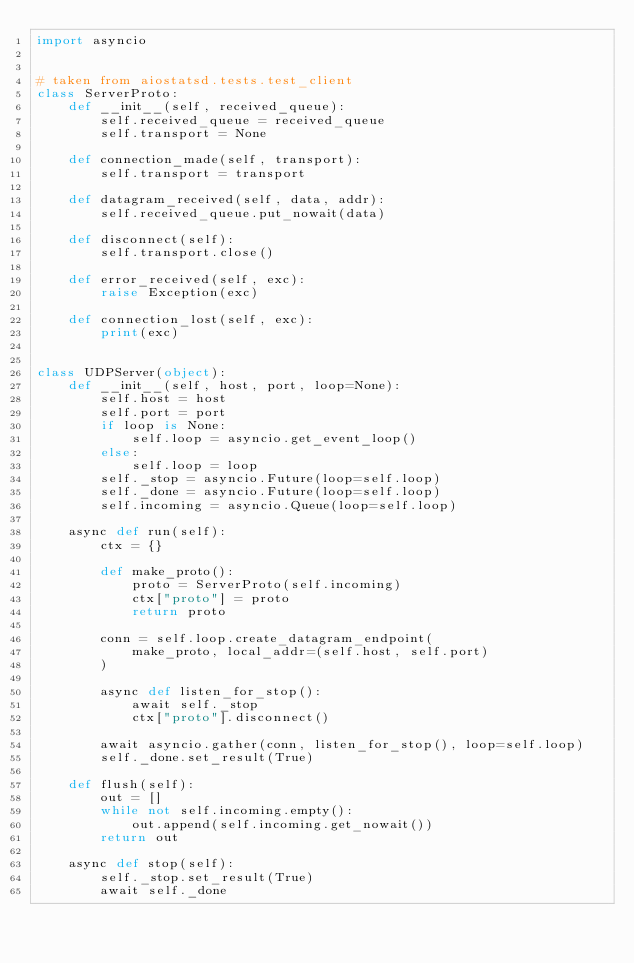<code> <loc_0><loc_0><loc_500><loc_500><_Python_>import asyncio


# taken from aiostatsd.tests.test_client
class ServerProto:
    def __init__(self, received_queue):
        self.received_queue = received_queue
        self.transport = None

    def connection_made(self, transport):
        self.transport = transport

    def datagram_received(self, data, addr):
        self.received_queue.put_nowait(data)

    def disconnect(self):
        self.transport.close()

    def error_received(self, exc):
        raise Exception(exc)

    def connection_lost(self, exc):
        print(exc)


class UDPServer(object):
    def __init__(self, host, port, loop=None):
        self.host = host
        self.port = port
        if loop is None:
            self.loop = asyncio.get_event_loop()
        else:
            self.loop = loop
        self._stop = asyncio.Future(loop=self.loop)
        self._done = asyncio.Future(loop=self.loop)
        self.incoming = asyncio.Queue(loop=self.loop)

    async def run(self):
        ctx = {}

        def make_proto():
            proto = ServerProto(self.incoming)
            ctx["proto"] = proto
            return proto

        conn = self.loop.create_datagram_endpoint(
            make_proto, local_addr=(self.host, self.port)
        )

        async def listen_for_stop():
            await self._stop
            ctx["proto"].disconnect()

        await asyncio.gather(conn, listen_for_stop(), loop=self.loop)
        self._done.set_result(True)

    def flush(self):
        out = []
        while not self.incoming.empty():
            out.append(self.incoming.get_nowait())
        return out

    async def stop(self):
        self._stop.set_result(True)
        await self._done
</code> 